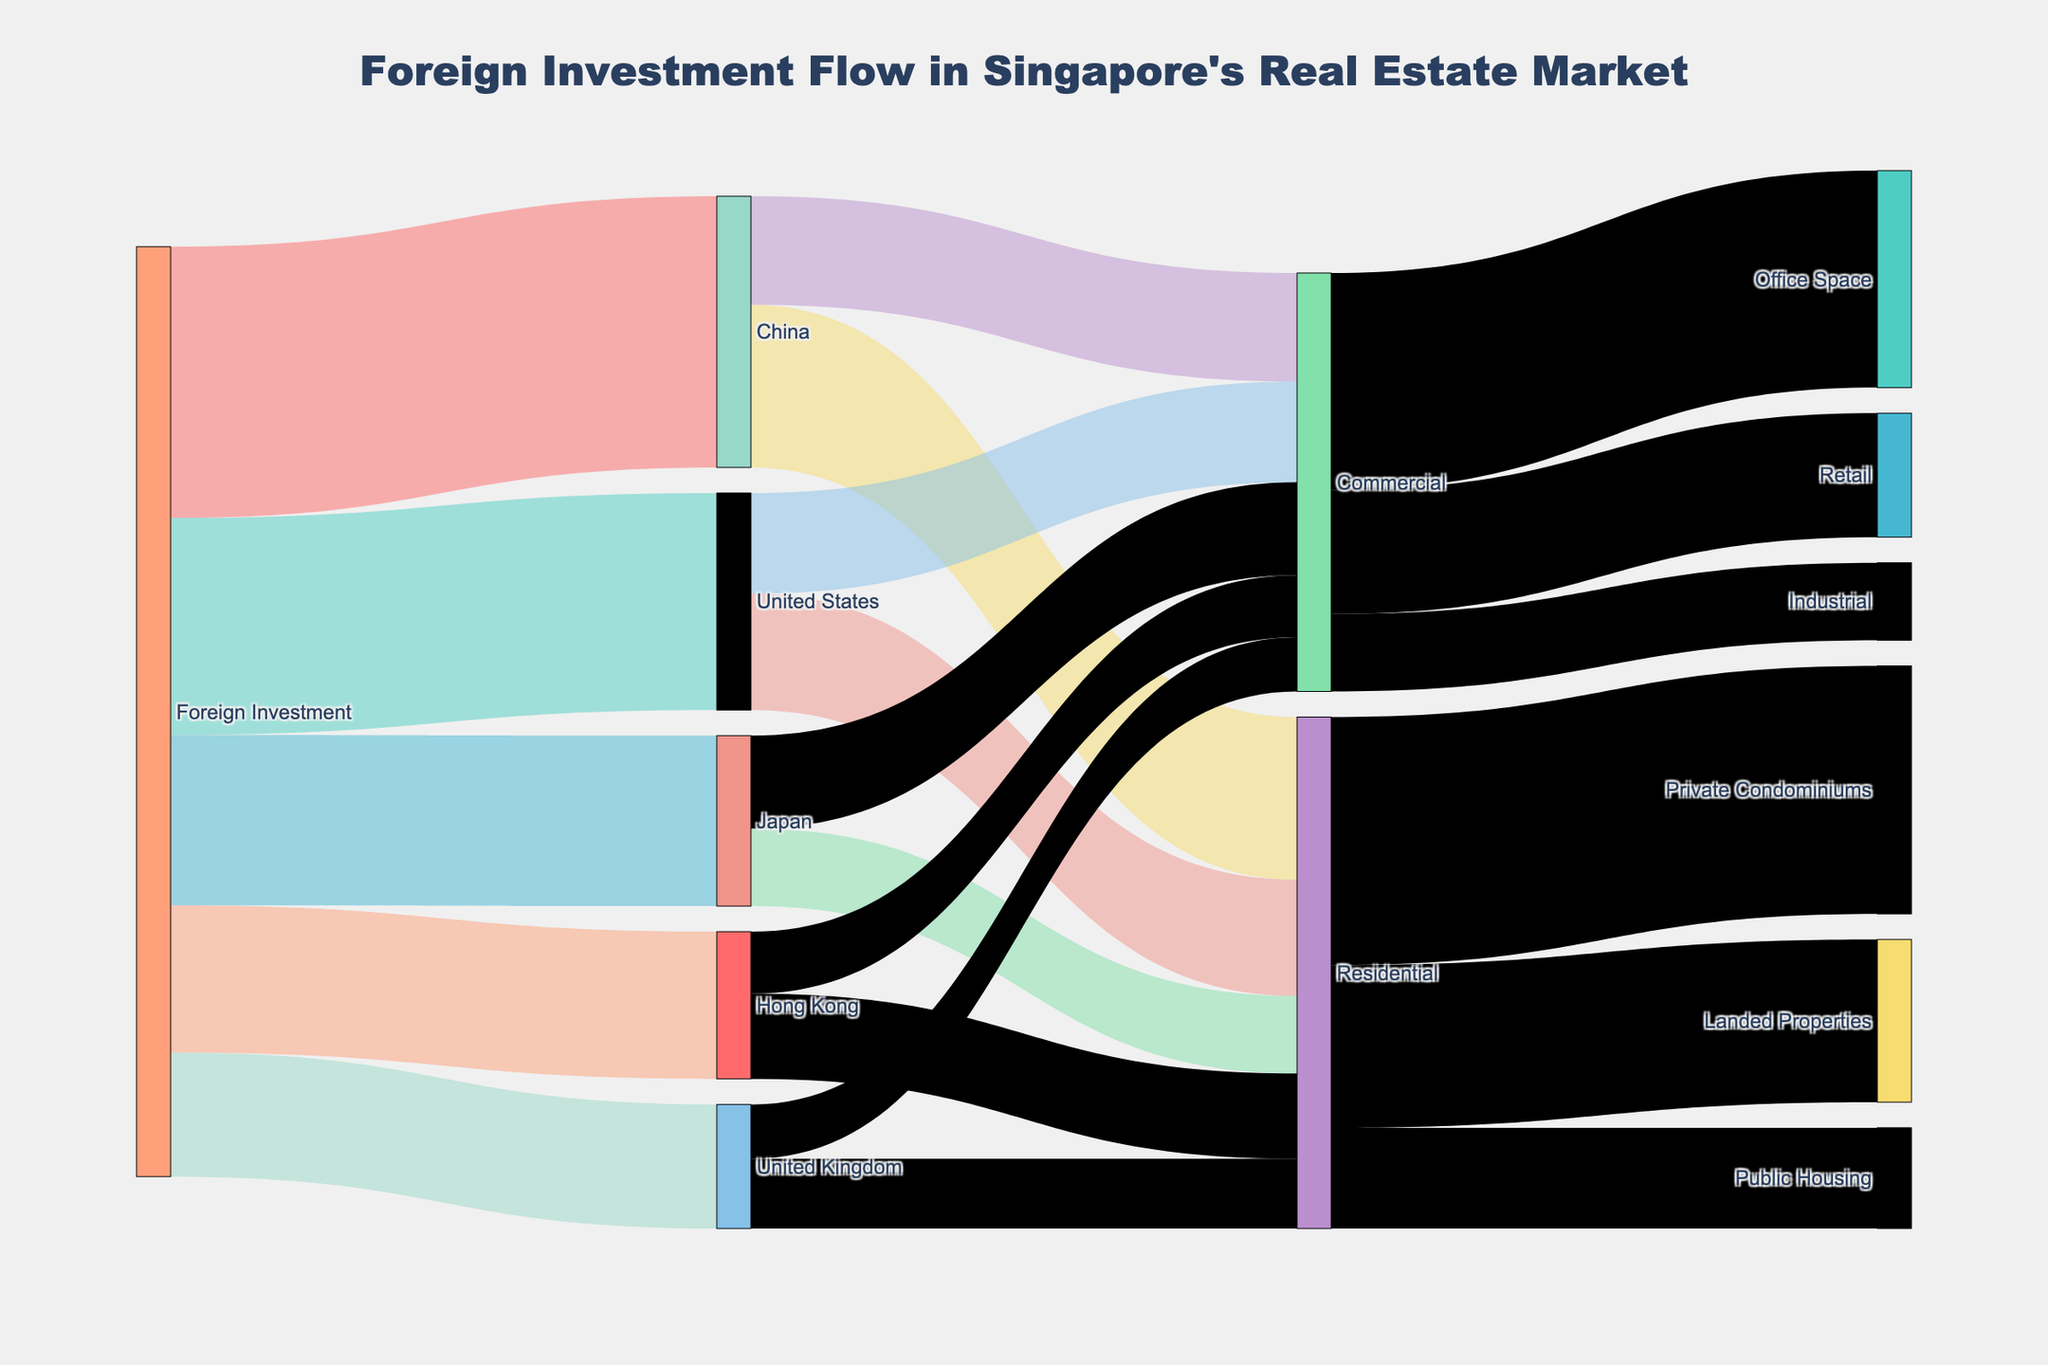What's the main title of the Sankey Diagram? The main title is typically located at the top of the figure and describes the key focus. In this case, it is "Foreign Investment Flow in Singapore's Real Estate Market".
Answer: Foreign Investment Flow in Singapore's Real Estate Market Which country has the highest foreign investment in Singapore's real estate market? By looking at the first set of nodes, we compare the values connected to "Foreign Investment". China has the highest investment at 3500 units.
Answer: China What is the difference between the residential investments from the United States and Japan? United States invests 1500 units in residential, while Japan invests 1000 units. The difference is calculated by subtracting 1000 from 1500.
Answer: 500 Which sector receives the least investment from China? From the sankey diagram segment where China branches out, the investments are in Residential (2100) and Commercial (1400). The least is Commercial.
Answer: Commercial Summarize the total investment in retail spaces from all countries. Retail spaces are under the Commercial category, with total investment values from all countries adding up to 1600 units in the Retail sector.
Answer: 1600 Which sector received the highest overall investments in the Residential category? For Residential investments, Private Condominiums (3200), Landed Properties (2100), and Public Housing (1300) are given as targets. Private Condominiums received the highest.
Answer: Private Condominiums How much more investment is there in office space compared to industrial space? For office space, the total investment is 2800, and for industrial space, it is 1000. The difference is 2800 minus 1000.
Answer: 1800 Which country has the most balanced investment between residential and commercial sectors? By checking investments in both sectors, several countries show respective values: China (Residential 2100, Commercial 1400), the United States (Residential 1500, Commercial 1300), Japan (Residential 1000, Commercial 1200), Hong Kong (Residential 1100, Commercial 800), and the United Kingdom (Residential 900, Commercial 700). The smallest difference between the sectors is for the United States at 200 units.
Answer: United States How much total investment does Singapore receive from Japan in the real estate market? Adding the investments from Japan in both Residential (1000) and Commercial (1200): 1000 + 1200 = 2200.
Answer: 2200 Which property type under residential investment has the second-highest amount of investment? The given property types under residential are Private Condominiums (3200), Landed Properties (2100), and Public Housing (1300). Landed Properties is the second-highest at 2100.
Answer: Landed Properties 